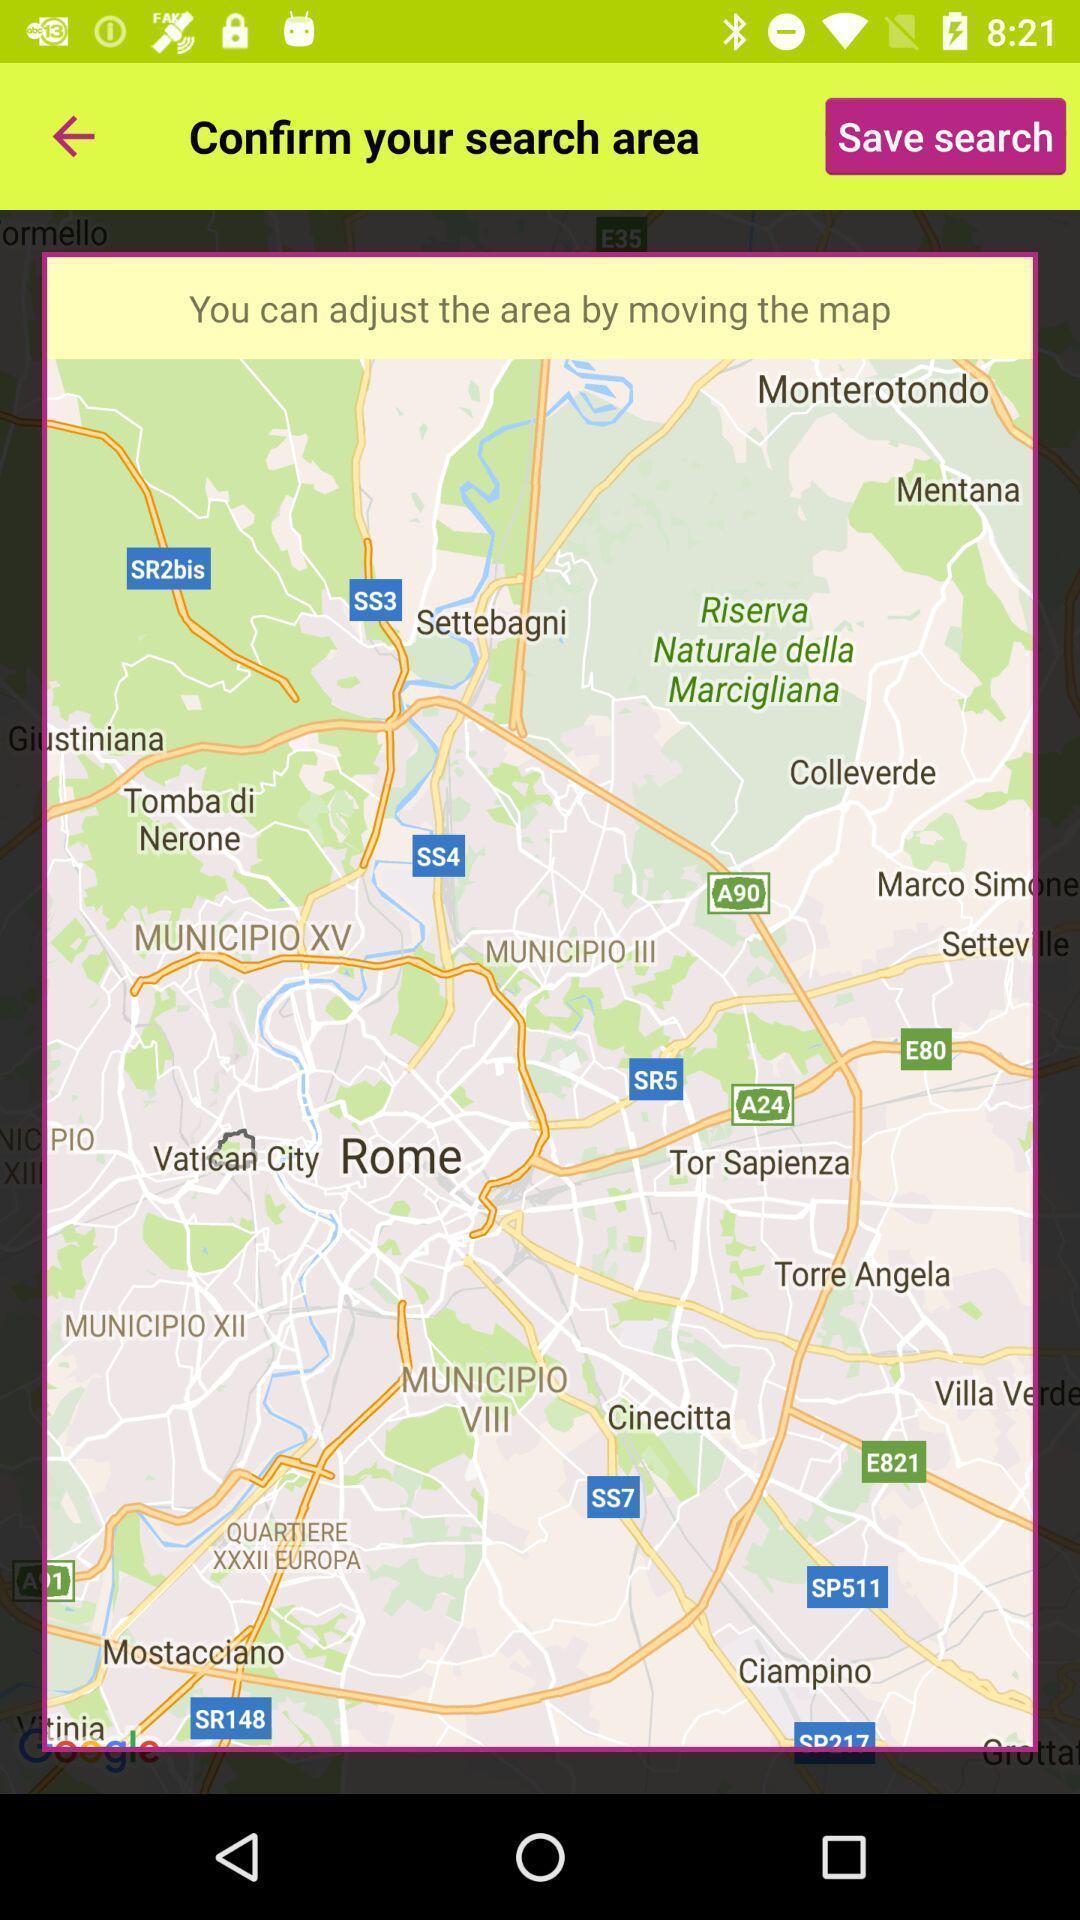Provide a description of this screenshot. Screen asking to confirm a search area. 